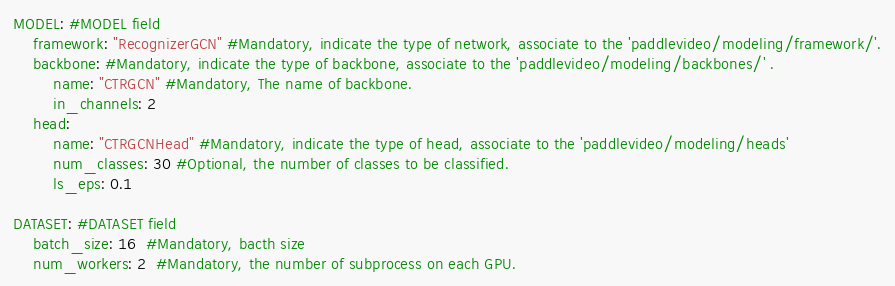<code> <loc_0><loc_0><loc_500><loc_500><_YAML_>MODEL: #MODEL field
    framework: "RecognizerGCN" #Mandatory, indicate the type of network, associate to the 'paddlevideo/modeling/framework/'.
    backbone: #Mandatory, indicate the type of backbone, associate to the 'paddlevideo/modeling/backbones/' .
        name: "CTRGCN" #Mandatory, The name of backbone.
        in_channels: 2
    head:
        name: "CTRGCNHead" #Mandatory, indicate the type of head, associate to the 'paddlevideo/modeling/heads'
        num_classes: 30 #Optional, the number of classes to be classified.
        ls_eps: 0.1

DATASET: #DATASET field
    batch_size: 16  #Mandatory, bacth size
    num_workers: 2  #Mandatory, the number of subprocess on each GPU.</code> 